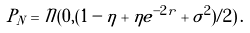<formula> <loc_0><loc_0><loc_500><loc_500>P _ { N } = { \mathcal { N } } ( 0 , ( 1 - \eta + \eta e ^ { - 2 r } + \sigma ^ { 2 } ) / 2 ) \, .</formula> 